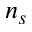<formula> <loc_0><loc_0><loc_500><loc_500>n _ { s }</formula> 